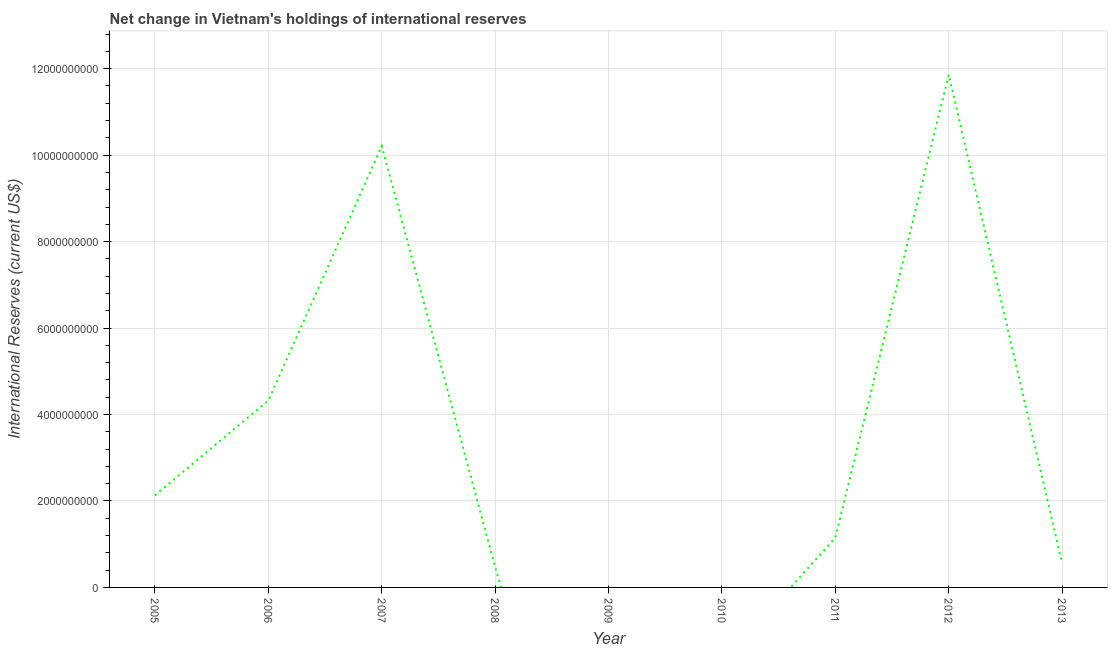Across all years, what is the maximum reserves and related items?
Provide a short and direct response. 1.19e+1. Across all years, what is the minimum reserves and related items?
Keep it short and to the point. 0. What is the sum of the reserves and related items?
Offer a terse response. 3.07e+1. What is the difference between the reserves and related items in 2008 and 2013?
Your response must be concise. -8.34e+07. What is the average reserves and related items per year?
Provide a succinct answer. 3.41e+09. What is the median reserves and related items?
Provide a short and direct response. 1.15e+09. In how many years, is the reserves and related items greater than 10800000000 US$?
Offer a very short reply. 1. What is the ratio of the reserves and related items in 2005 to that in 2007?
Offer a terse response. 0.21. Is the reserves and related items in 2005 less than that in 2013?
Your answer should be very brief. No. Is the difference between the reserves and related items in 2011 and 2012 greater than the difference between any two years?
Provide a succinct answer. No. What is the difference between the highest and the second highest reserves and related items?
Your answer should be compact. 1.65e+09. What is the difference between the highest and the lowest reserves and related items?
Ensure brevity in your answer.  1.19e+1. Does the reserves and related items monotonically increase over the years?
Offer a very short reply. No. How many years are there in the graph?
Make the answer very short. 9. What is the difference between two consecutive major ticks on the Y-axis?
Your response must be concise. 2.00e+09. Are the values on the major ticks of Y-axis written in scientific E-notation?
Make the answer very short. No. What is the title of the graph?
Your response must be concise. Net change in Vietnam's holdings of international reserves. What is the label or title of the Y-axis?
Your answer should be very brief. International Reserves (current US$). What is the International Reserves (current US$) of 2005?
Offer a very short reply. 2.13e+09. What is the International Reserves (current US$) of 2006?
Your answer should be very brief. 4.32e+09. What is the International Reserves (current US$) of 2007?
Keep it short and to the point. 1.02e+1. What is the International Reserves (current US$) in 2008?
Your answer should be compact. 4.74e+08. What is the International Reserves (current US$) in 2009?
Ensure brevity in your answer.  0. What is the International Reserves (current US$) of 2010?
Give a very brief answer. 0. What is the International Reserves (current US$) of 2011?
Offer a very short reply. 1.15e+09. What is the International Reserves (current US$) of 2012?
Your response must be concise. 1.19e+1. What is the International Reserves (current US$) in 2013?
Provide a succinct answer. 5.57e+08. What is the difference between the International Reserves (current US$) in 2005 and 2006?
Your response must be concise. -2.19e+09. What is the difference between the International Reserves (current US$) in 2005 and 2007?
Your response must be concise. -8.08e+09. What is the difference between the International Reserves (current US$) in 2005 and 2008?
Your answer should be compact. 1.66e+09. What is the difference between the International Reserves (current US$) in 2005 and 2011?
Offer a terse response. 9.79e+08. What is the difference between the International Reserves (current US$) in 2005 and 2012?
Keep it short and to the point. -9.73e+09. What is the difference between the International Reserves (current US$) in 2005 and 2013?
Offer a terse response. 1.57e+09. What is the difference between the International Reserves (current US$) in 2006 and 2007?
Ensure brevity in your answer.  -5.89e+09. What is the difference between the International Reserves (current US$) in 2006 and 2008?
Provide a short and direct response. 3.85e+09. What is the difference between the International Reserves (current US$) in 2006 and 2011?
Keep it short and to the point. 3.17e+09. What is the difference between the International Reserves (current US$) in 2006 and 2012?
Your answer should be compact. -7.54e+09. What is the difference between the International Reserves (current US$) in 2006 and 2013?
Offer a terse response. 3.77e+09. What is the difference between the International Reserves (current US$) in 2007 and 2008?
Offer a very short reply. 9.74e+09. What is the difference between the International Reserves (current US$) in 2007 and 2011?
Offer a very short reply. 9.06e+09. What is the difference between the International Reserves (current US$) in 2007 and 2012?
Keep it short and to the point. -1.65e+09. What is the difference between the International Reserves (current US$) in 2007 and 2013?
Your answer should be compact. 9.65e+09. What is the difference between the International Reserves (current US$) in 2008 and 2011?
Offer a terse response. -6.77e+08. What is the difference between the International Reserves (current US$) in 2008 and 2012?
Offer a terse response. -1.14e+1. What is the difference between the International Reserves (current US$) in 2008 and 2013?
Your answer should be compact. -8.34e+07. What is the difference between the International Reserves (current US$) in 2011 and 2012?
Provide a succinct answer. -1.07e+1. What is the difference between the International Reserves (current US$) in 2011 and 2013?
Make the answer very short. 5.94e+08. What is the difference between the International Reserves (current US$) in 2012 and 2013?
Offer a terse response. 1.13e+1. What is the ratio of the International Reserves (current US$) in 2005 to that in 2006?
Your answer should be very brief. 0.49. What is the ratio of the International Reserves (current US$) in 2005 to that in 2007?
Your response must be concise. 0.21. What is the ratio of the International Reserves (current US$) in 2005 to that in 2008?
Provide a short and direct response. 4.5. What is the ratio of the International Reserves (current US$) in 2005 to that in 2011?
Your answer should be compact. 1.85. What is the ratio of the International Reserves (current US$) in 2005 to that in 2012?
Offer a very short reply. 0.18. What is the ratio of the International Reserves (current US$) in 2005 to that in 2013?
Make the answer very short. 3.83. What is the ratio of the International Reserves (current US$) in 2006 to that in 2007?
Provide a succinct answer. 0.42. What is the ratio of the International Reserves (current US$) in 2006 to that in 2008?
Your answer should be very brief. 9.13. What is the ratio of the International Reserves (current US$) in 2006 to that in 2011?
Provide a short and direct response. 3.76. What is the ratio of the International Reserves (current US$) in 2006 to that in 2012?
Make the answer very short. 0.36. What is the ratio of the International Reserves (current US$) in 2006 to that in 2013?
Keep it short and to the point. 7.76. What is the ratio of the International Reserves (current US$) in 2007 to that in 2008?
Make the answer very short. 21.56. What is the ratio of the International Reserves (current US$) in 2007 to that in 2011?
Give a very brief answer. 8.87. What is the ratio of the International Reserves (current US$) in 2007 to that in 2012?
Make the answer very short. 0.86. What is the ratio of the International Reserves (current US$) in 2007 to that in 2013?
Your answer should be very brief. 18.34. What is the ratio of the International Reserves (current US$) in 2008 to that in 2011?
Provide a succinct answer. 0.41. What is the ratio of the International Reserves (current US$) in 2011 to that in 2012?
Your answer should be compact. 0.1. What is the ratio of the International Reserves (current US$) in 2011 to that in 2013?
Provide a short and direct response. 2.07. What is the ratio of the International Reserves (current US$) in 2012 to that in 2013?
Your answer should be very brief. 21.29. 